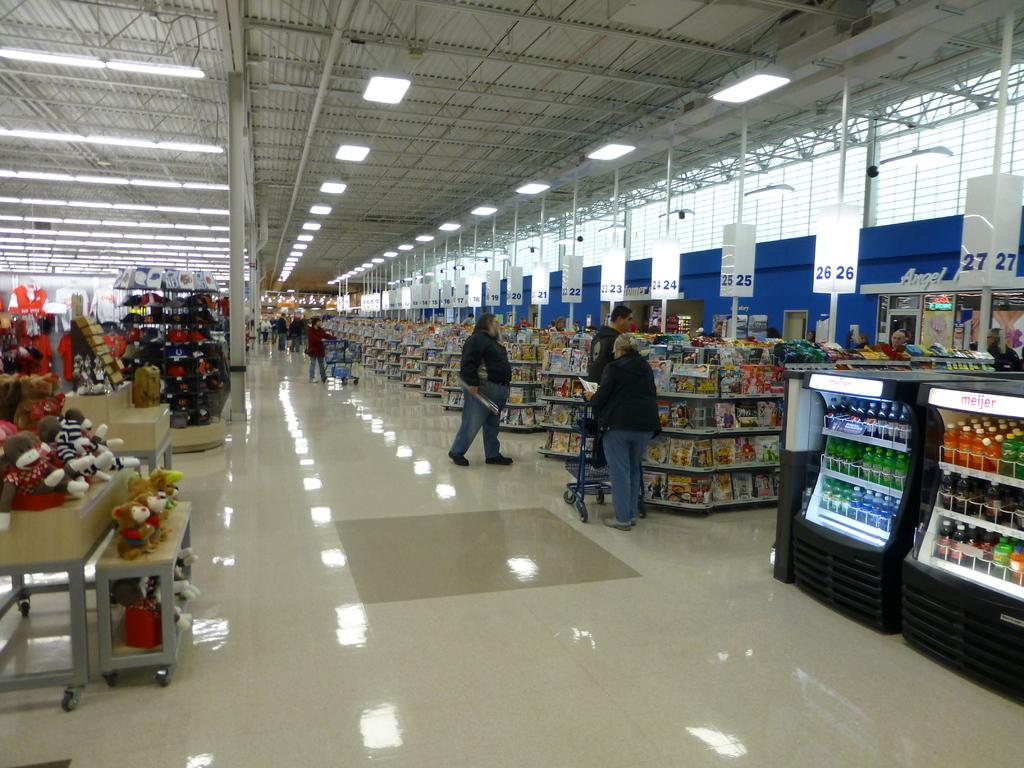<image>
Give a short and clear explanation of the subsequent image. a row of check out lines at a store with number 26 lit up 